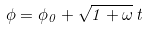<formula> <loc_0><loc_0><loc_500><loc_500>\phi = \phi _ { 0 } + \sqrt { 1 + \omega } \, t</formula> 